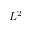<formula> <loc_0><loc_0><loc_500><loc_500>L ^ { 2 }</formula> 